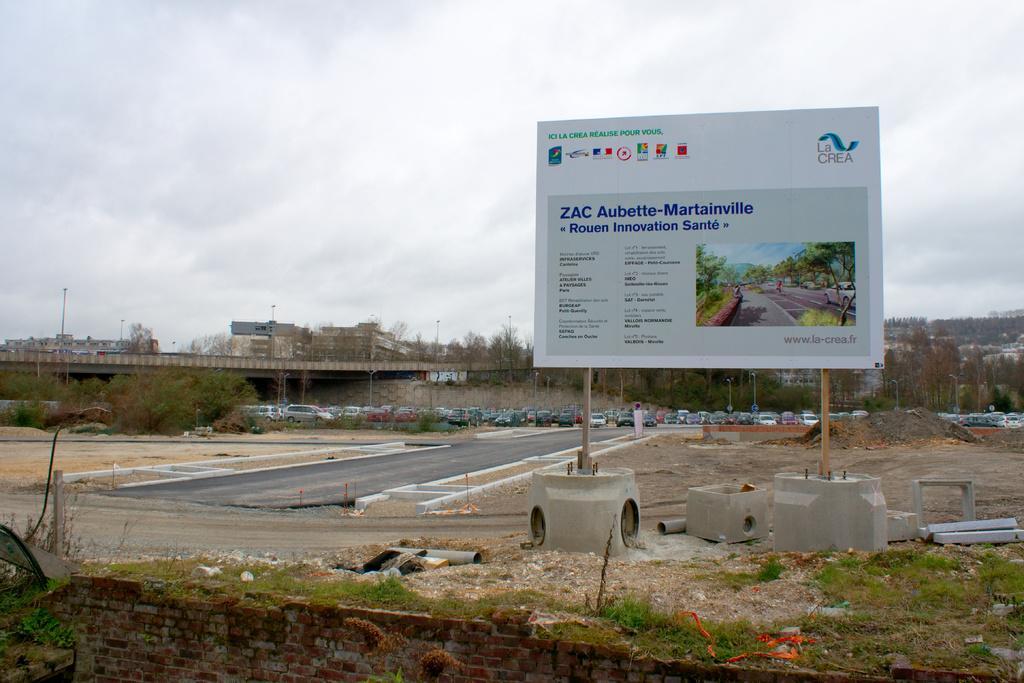Could you give a brief overview of what you see in this image? This image consists of a hoarding. At the bottom, there is green grass and a wall. In the middle, there is a road. In the background, we can see many cars parked. On the left, there is a bridge. At the top, there are clouds in the sky. 